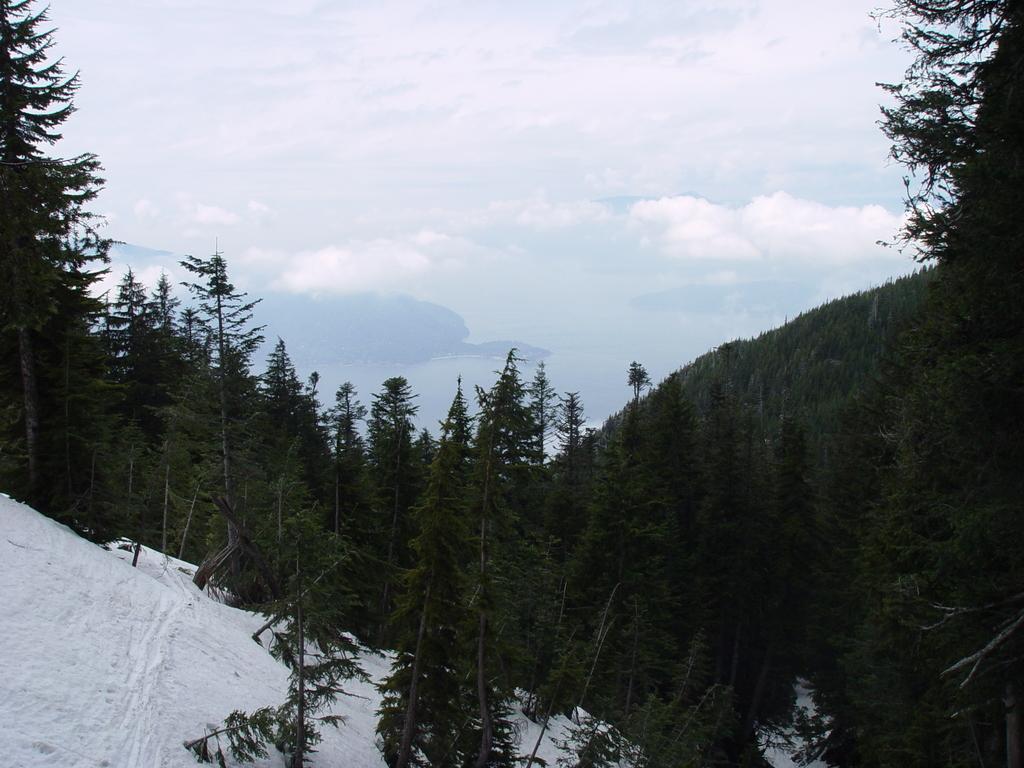Describe this image in one or two sentences. In the foreground of this image, there are trees on mountains, snow on the left bottom corner of the image and the sky and cloud on the top. 